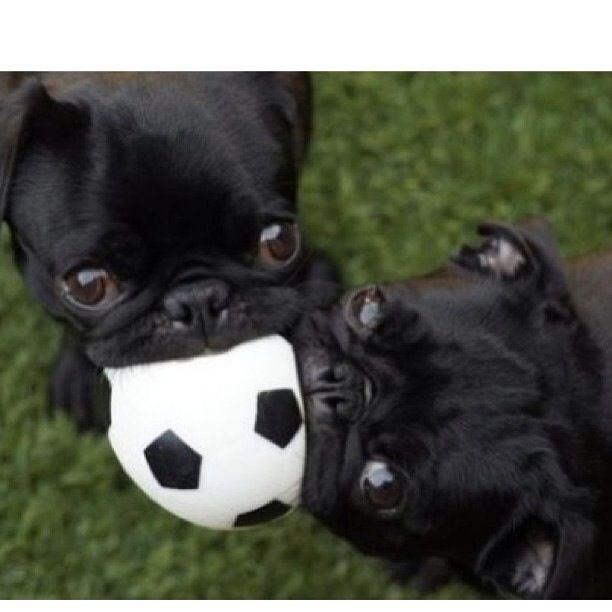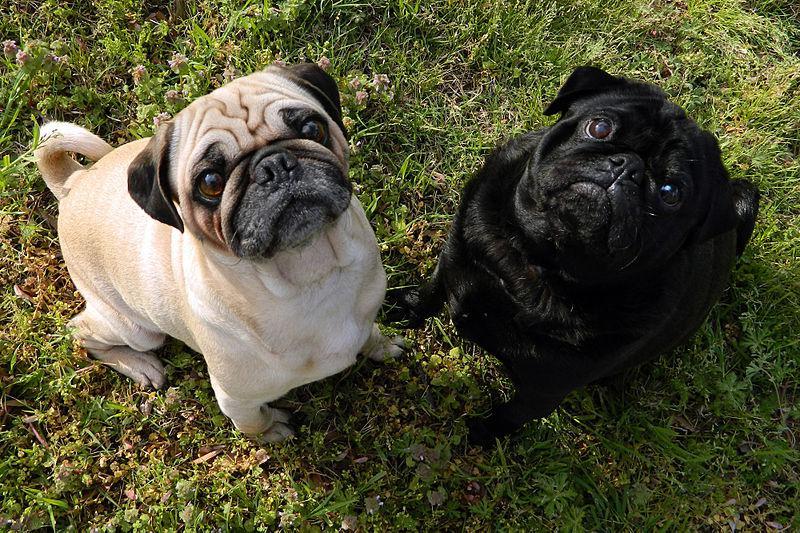The first image is the image on the left, the second image is the image on the right. Analyze the images presented: Is the assertion "The left image includes at least one black pug with something black-and-white grasped in its mouth." valid? Answer yes or no. Yes. The first image is the image on the left, the second image is the image on the right. Evaluate the accuracy of this statement regarding the images: "The left image contains at least one pug dog outside on grass chewing on an item.". Is it true? Answer yes or no. Yes. 